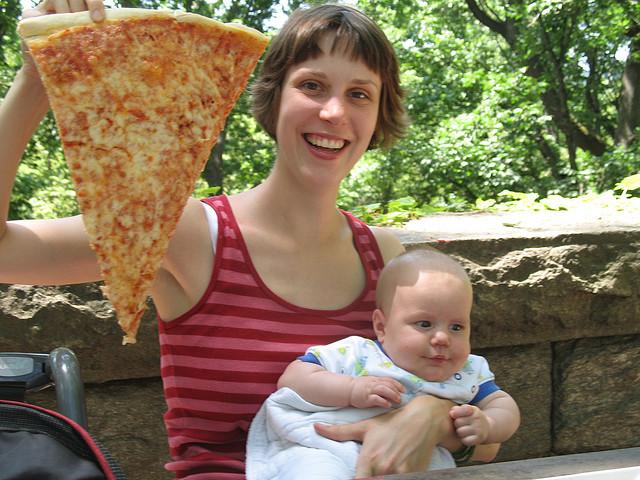Is there an adult depicted?
Be succinct. Yes. Is this girl excited?
Concise answer only. Yes. Where is the toddler?
Write a very short answer. Lap. What is she sitting on?
Keep it brief. Bench. Is there ketchup on the food?
Be succinct. No. Would this top be considered sleeveless?
Short answer required. Yes. How many women are there?
Keep it brief. 1. Is the woman's hair down or pulled back?
Keep it brief. Down. Does the woman have makeup on?
Write a very short answer. Yes. What is she holding?
Concise answer only. Pizza. Is the woman brushing her teeth in a wedding dress?
Concise answer only. No. How many bracelets is the woman on the right wearing?
Answer briefly. 0. Is this a normal size slice of pizza?
Keep it brief. No. What is the woman doing with the object in her right hand?
Answer briefly. Holding pizza. Is it night or day when this picture is taken?
Give a very brief answer. Day. 